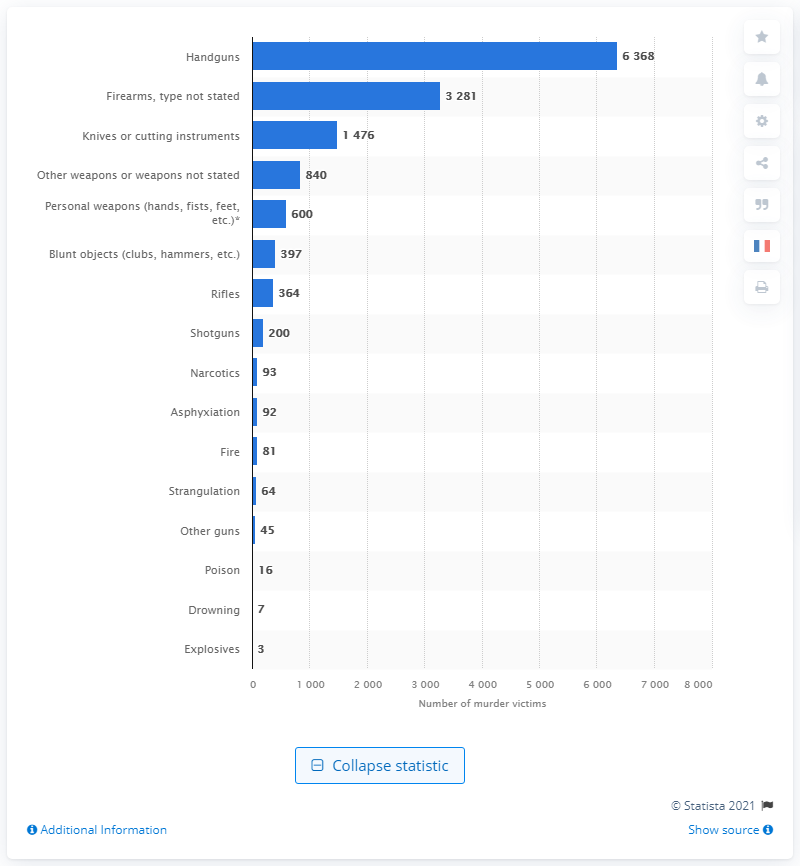Draw attention to some important aspects in this diagram. According to data, handguns are the most commonly used murder weapon in the United States. 